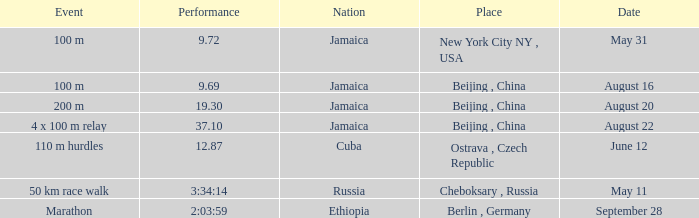What is the Place associated with Cuba? Ostrava , Czech Republic. 